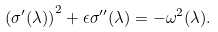<formula> <loc_0><loc_0><loc_500><loc_500>\left ( \sigma ^ { \prime } ( \lambda ) \right ) ^ { 2 } + \epsilon \sigma ^ { \prime \prime } ( \lambda ) = - \omega ^ { 2 } ( \lambda ) .</formula> 